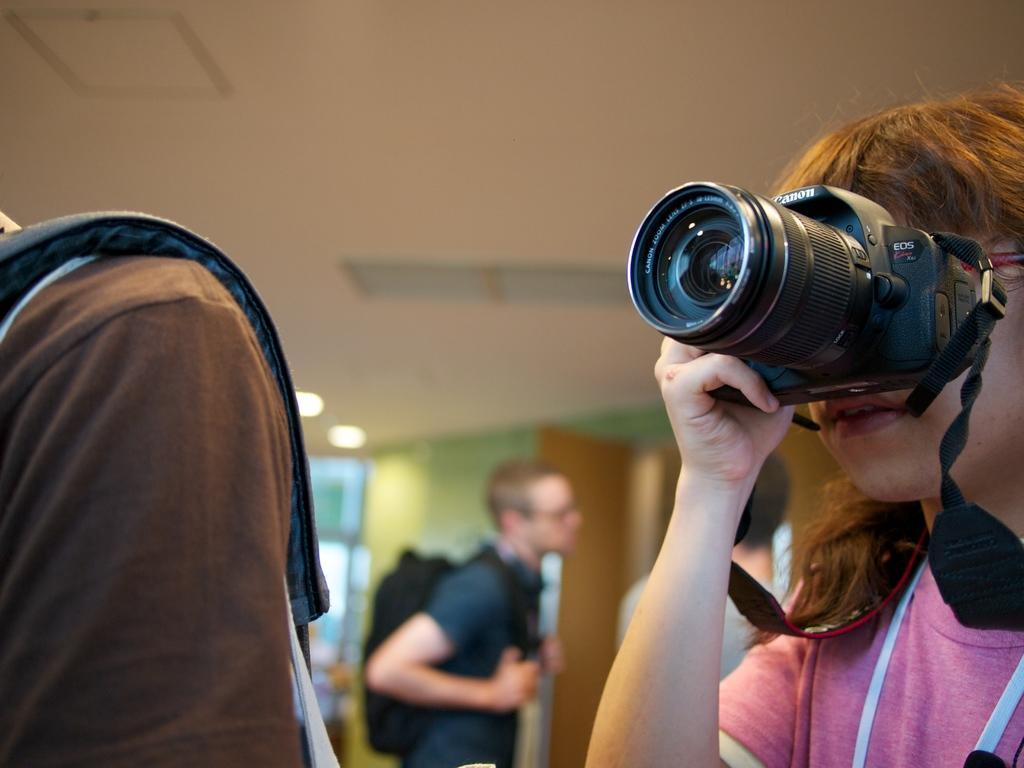Could you give a brief overview of what you see in this image? In this image, There is a girl holding a camera and in the right side there is a person standing and carrying a bag, In the background there is a man standing and there is a roof of white color and there is a yellow color door. 